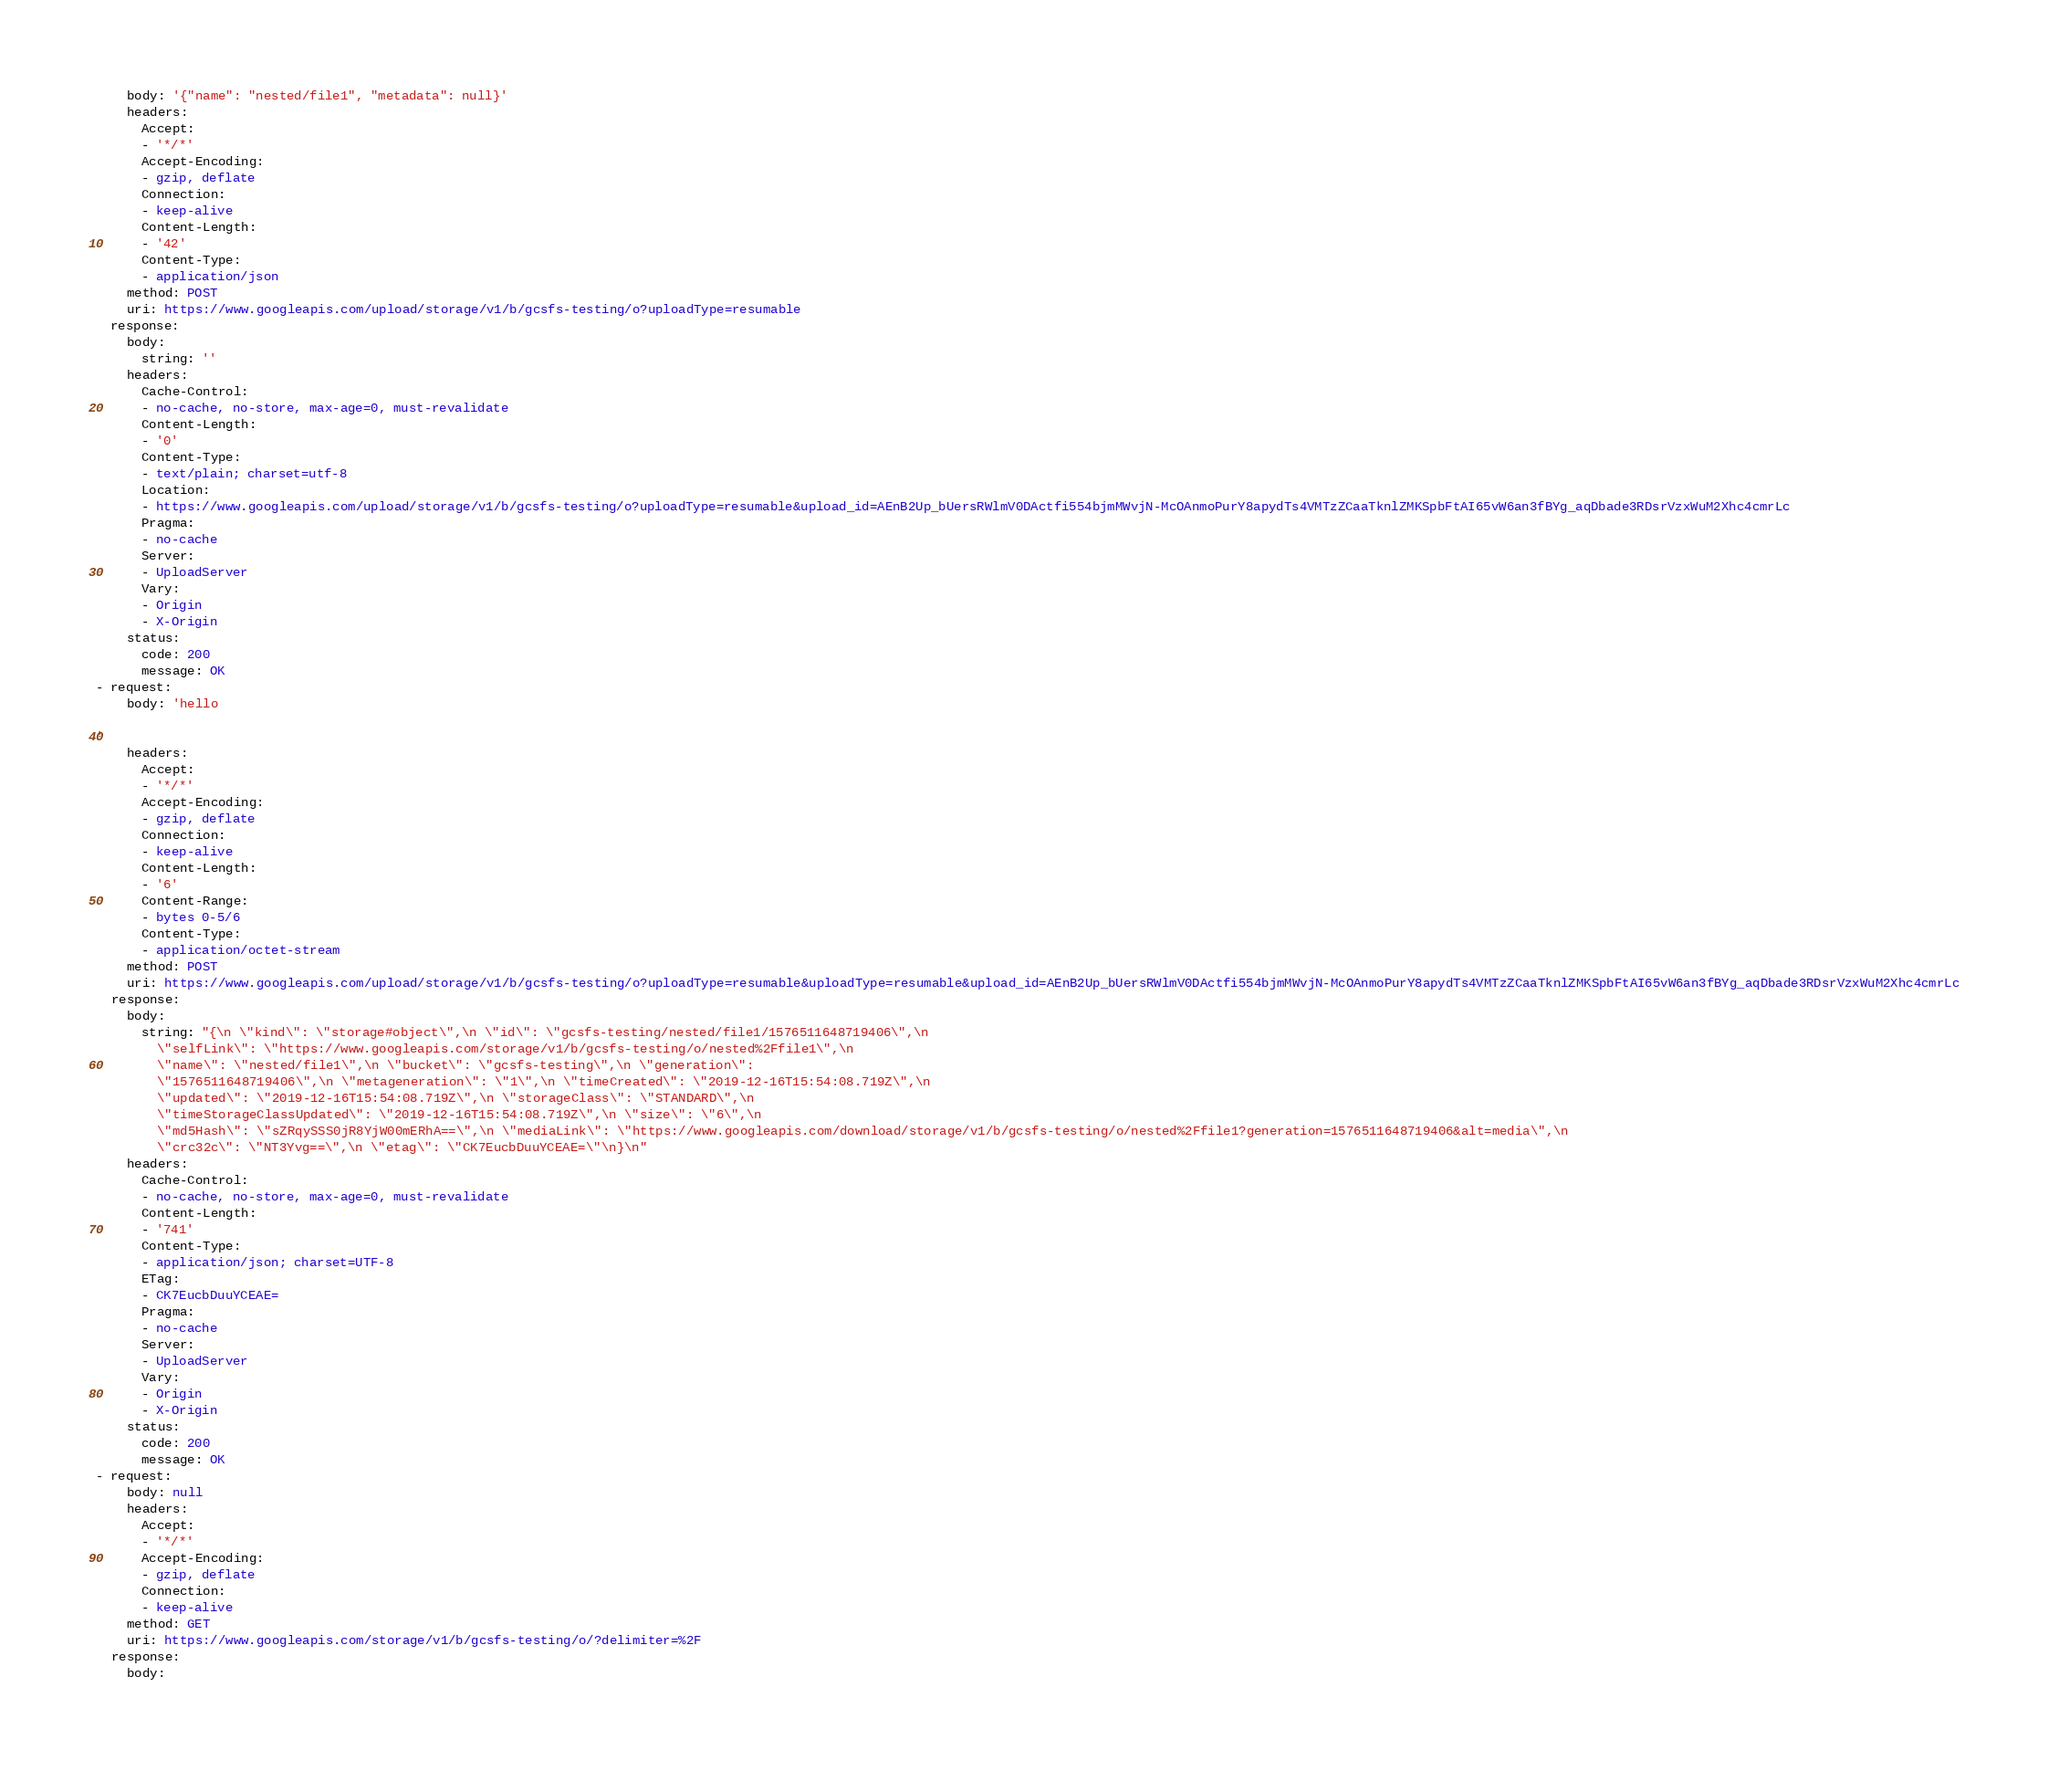<code> <loc_0><loc_0><loc_500><loc_500><_YAML_>    body: '{"name": "nested/file1", "metadata": null}'
    headers:
      Accept:
      - '*/*'
      Accept-Encoding:
      - gzip, deflate
      Connection:
      - keep-alive
      Content-Length:
      - '42'
      Content-Type:
      - application/json
    method: POST
    uri: https://www.googleapis.com/upload/storage/v1/b/gcsfs-testing/o?uploadType=resumable
  response:
    body:
      string: ''
    headers:
      Cache-Control:
      - no-cache, no-store, max-age=0, must-revalidate
      Content-Length:
      - '0'
      Content-Type:
      - text/plain; charset=utf-8
      Location:
      - https://www.googleapis.com/upload/storage/v1/b/gcsfs-testing/o?uploadType=resumable&upload_id=AEnB2Up_bUersRWlmV0DActfi554bjmMWvjN-McOAnmoPurY8apydTs4VMTzZCaaTknlZMKSpbFtAI65vW6an3fBYg_aqDbade3RDsrVzxWuM2Xhc4cmrLc
      Pragma:
      - no-cache
      Server:
      - UploadServer
      Vary:
      - Origin
      - X-Origin
    status:
      code: 200
      message: OK
- request:
    body: 'hello

'
    headers:
      Accept:
      - '*/*'
      Accept-Encoding:
      - gzip, deflate
      Connection:
      - keep-alive
      Content-Length:
      - '6'
      Content-Range:
      - bytes 0-5/6
      Content-Type:
      - application/octet-stream
    method: POST
    uri: https://www.googleapis.com/upload/storage/v1/b/gcsfs-testing/o?uploadType=resumable&uploadType=resumable&upload_id=AEnB2Up_bUersRWlmV0DActfi554bjmMWvjN-McOAnmoPurY8apydTs4VMTzZCaaTknlZMKSpbFtAI65vW6an3fBYg_aqDbade3RDsrVzxWuM2Xhc4cmrLc
  response:
    body:
      string: "{\n \"kind\": \"storage#object\",\n \"id\": \"gcsfs-testing/nested/file1/1576511648719406\",\n
        \"selfLink\": \"https://www.googleapis.com/storage/v1/b/gcsfs-testing/o/nested%2Ffile1\",\n
        \"name\": \"nested/file1\",\n \"bucket\": \"gcsfs-testing\",\n \"generation\":
        \"1576511648719406\",\n \"metageneration\": \"1\",\n \"timeCreated\": \"2019-12-16T15:54:08.719Z\",\n
        \"updated\": \"2019-12-16T15:54:08.719Z\",\n \"storageClass\": \"STANDARD\",\n
        \"timeStorageClassUpdated\": \"2019-12-16T15:54:08.719Z\",\n \"size\": \"6\",\n
        \"md5Hash\": \"sZRqySSS0jR8YjW00mERhA==\",\n \"mediaLink\": \"https://www.googleapis.com/download/storage/v1/b/gcsfs-testing/o/nested%2Ffile1?generation=1576511648719406&alt=media\",\n
        \"crc32c\": \"NT3Yvg==\",\n \"etag\": \"CK7EucbDuuYCEAE=\"\n}\n"
    headers:
      Cache-Control:
      - no-cache, no-store, max-age=0, must-revalidate
      Content-Length:
      - '741'
      Content-Type:
      - application/json; charset=UTF-8
      ETag:
      - CK7EucbDuuYCEAE=
      Pragma:
      - no-cache
      Server:
      - UploadServer
      Vary:
      - Origin
      - X-Origin
    status:
      code: 200
      message: OK
- request:
    body: null
    headers:
      Accept:
      - '*/*'
      Accept-Encoding:
      - gzip, deflate
      Connection:
      - keep-alive
    method: GET
    uri: https://www.googleapis.com/storage/v1/b/gcsfs-testing/o/?delimiter=%2F
  response:
    body:</code> 